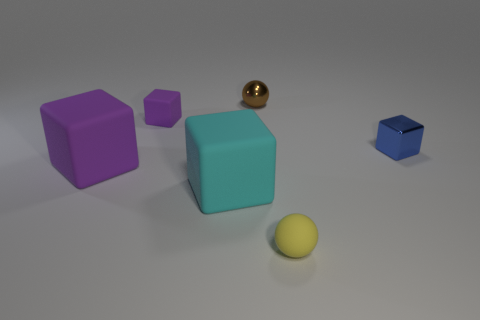Can you tell me which object in this image has the smallest shadow? The object with the smallest shadow in this image appears to be the small blue cube on the right side. 